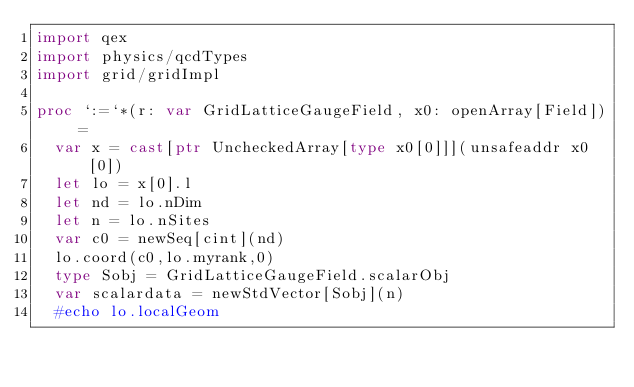Convert code to text. <code><loc_0><loc_0><loc_500><loc_500><_Nim_>import qex
import physics/qcdTypes
import grid/gridImpl

proc `:=`*(r: var GridLatticeGaugeField, x0: openArray[Field]) =
  var x = cast[ptr UncheckedArray[type x0[0]]](unsafeaddr x0[0])
  let lo = x[0].l
  let nd = lo.nDim
  let n = lo.nSites
  var c0 = newSeq[cint](nd)
  lo.coord(c0,lo.myrank,0)
  type Sobj = GridLatticeGaugeField.scalarObj
  var scalardata = newStdVector[Sobj](n)
  #echo lo.localGeom</code> 